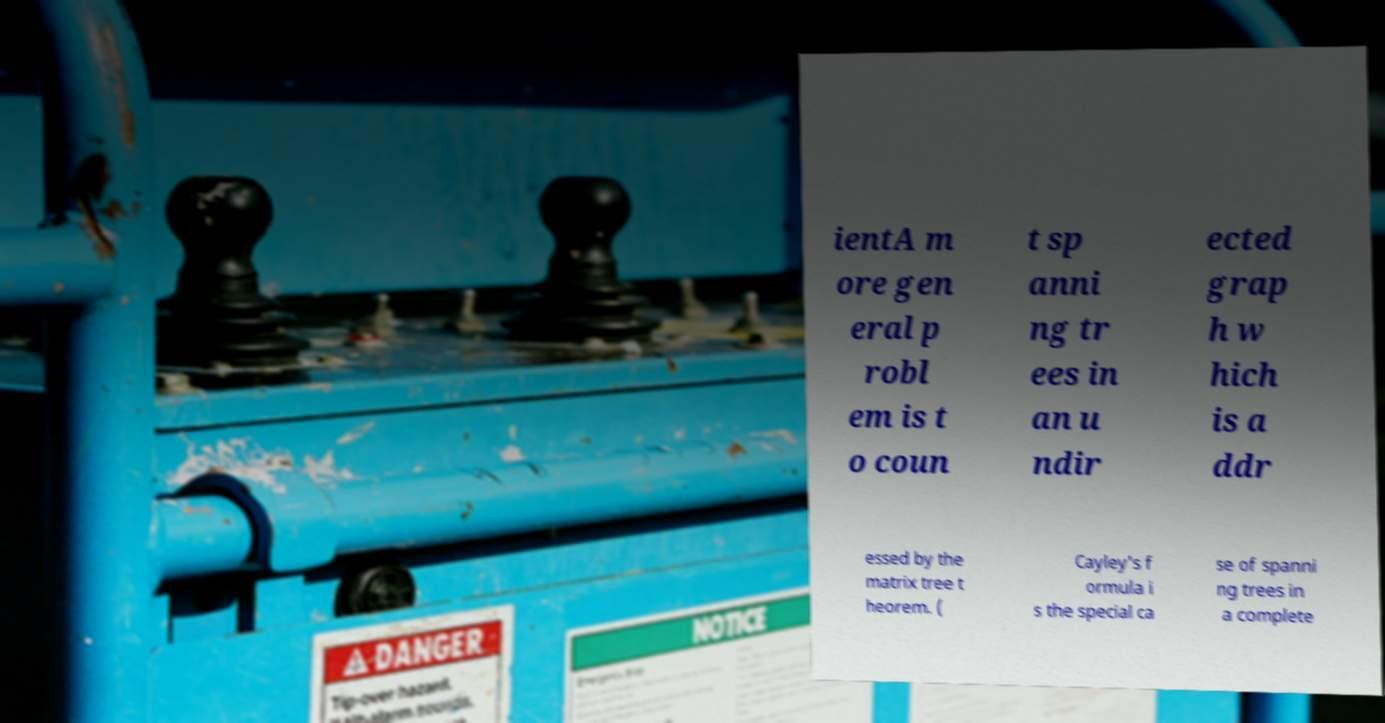Please identify and transcribe the text found in this image. ientA m ore gen eral p robl em is t o coun t sp anni ng tr ees in an u ndir ected grap h w hich is a ddr essed by the matrix tree t heorem. ( Cayley's f ormula i s the special ca se of spanni ng trees in a complete 